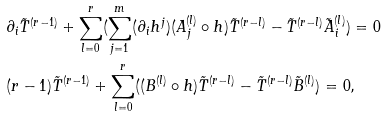Convert formula to latex. <formula><loc_0><loc_0><loc_500><loc_500>& \partial _ { i } \tilde { T } ^ { ( r - 1 ) } + \sum _ { l = 0 } ^ { r } ( \sum _ { j = 1 } ^ { m } ( \partial _ { i } { h ^ { j } } ) ( A _ { j } ^ { ( l ) } \circ h ) \tilde { T } ^ { ( r - l ) } - \tilde { T } ^ { ( r - l ) } \tilde { A } _ { i } ^ { ( l ) } ) = 0 \\ & ( r - 1 ) \tilde { T } ^ { ( r - 1 ) } + \sum _ { l = 0 } ^ { r } ( ( B ^ { ( l ) } \circ h ) \tilde { T } ^ { ( r - l ) } - \tilde { T } ^ { ( r - l ) } \tilde { B } ^ { ( l ) } ) = 0 ,</formula> 